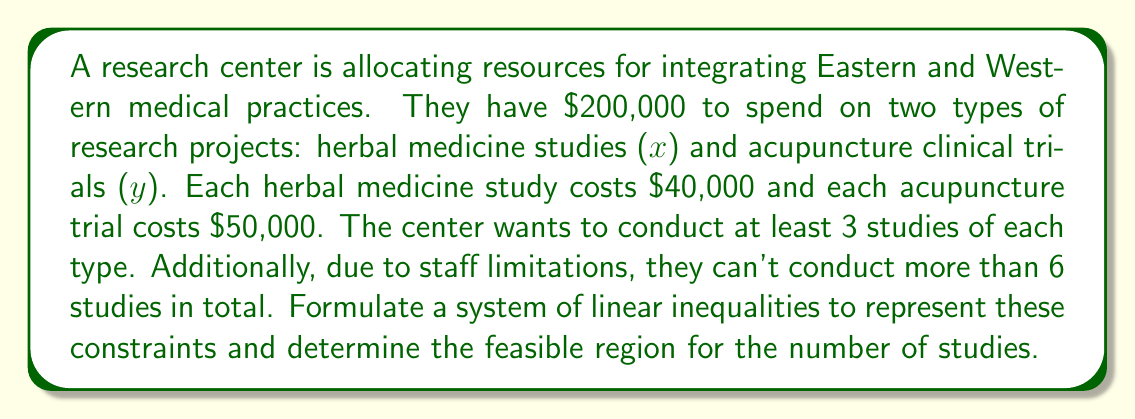What is the answer to this math problem? Let's break this down step-by-step:

1) Define variables:
   x = number of herbal medicine studies
   y = number of acupuncture clinical trials

2) Budget constraint:
   Cost of herbal studies + Cost of acupuncture trials ≤ Total budget
   $40,000x + $50,000y ≤ $200,000
   Simplifying: 40x + 50y ≤ 200

3) Minimum number of studies constraint:
   x ≥ 3 and y ≥ 3

4) Maximum total studies constraint:
   x + y ≤ 6

5) Non-negativity constraint:
   x ≥ 0 and y ≥ 0 (implied by constraint 3)

Therefore, our system of inequalities is:

$$\begin{cases}
40x + 50y \leq 200 \\
x \geq 3 \\
y \geq 3 \\
x + y \leq 6 \\
x, y \geq 0
\end{cases}$$

The feasible region is the area that satisfies all these inequalities simultaneously. It's bounded by the lines:

- 40x + 50y = 200 (budget line)
- x = 3 (minimum herbal studies)
- y = 3 (minimum acupuncture trials)
- x + y = 6 (maximum total studies)

The feasible region is the intersection of these constraints.
Answer: $$\begin{cases}
40x + 50y \leq 200 \\
x \geq 3 \\
y \geq 3 \\
x + y \leq 6 \\
x, y \geq 0
\end{cases}$$ 